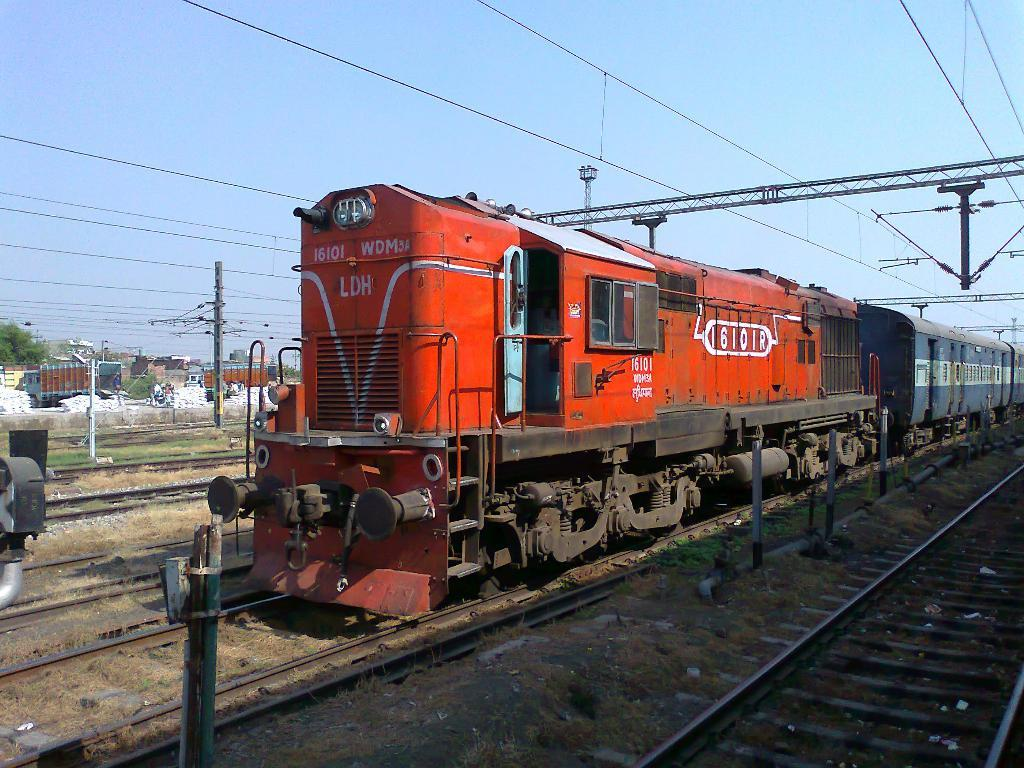<image>
Describe the image concisely. A red train with 16101 WDMY written across the front of it. 